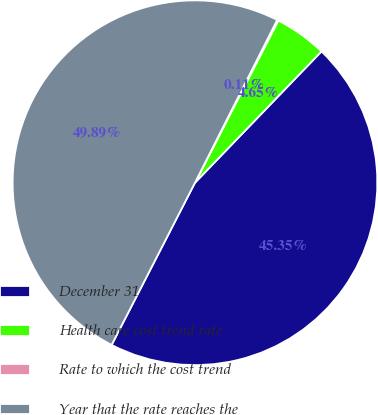<chart> <loc_0><loc_0><loc_500><loc_500><pie_chart><fcel>December 31<fcel>Health care cost trend rate<fcel>Rate to which the cost trend<fcel>Year that the rate reaches the<nl><fcel>45.35%<fcel>4.65%<fcel>0.11%<fcel>49.89%<nl></chart> 